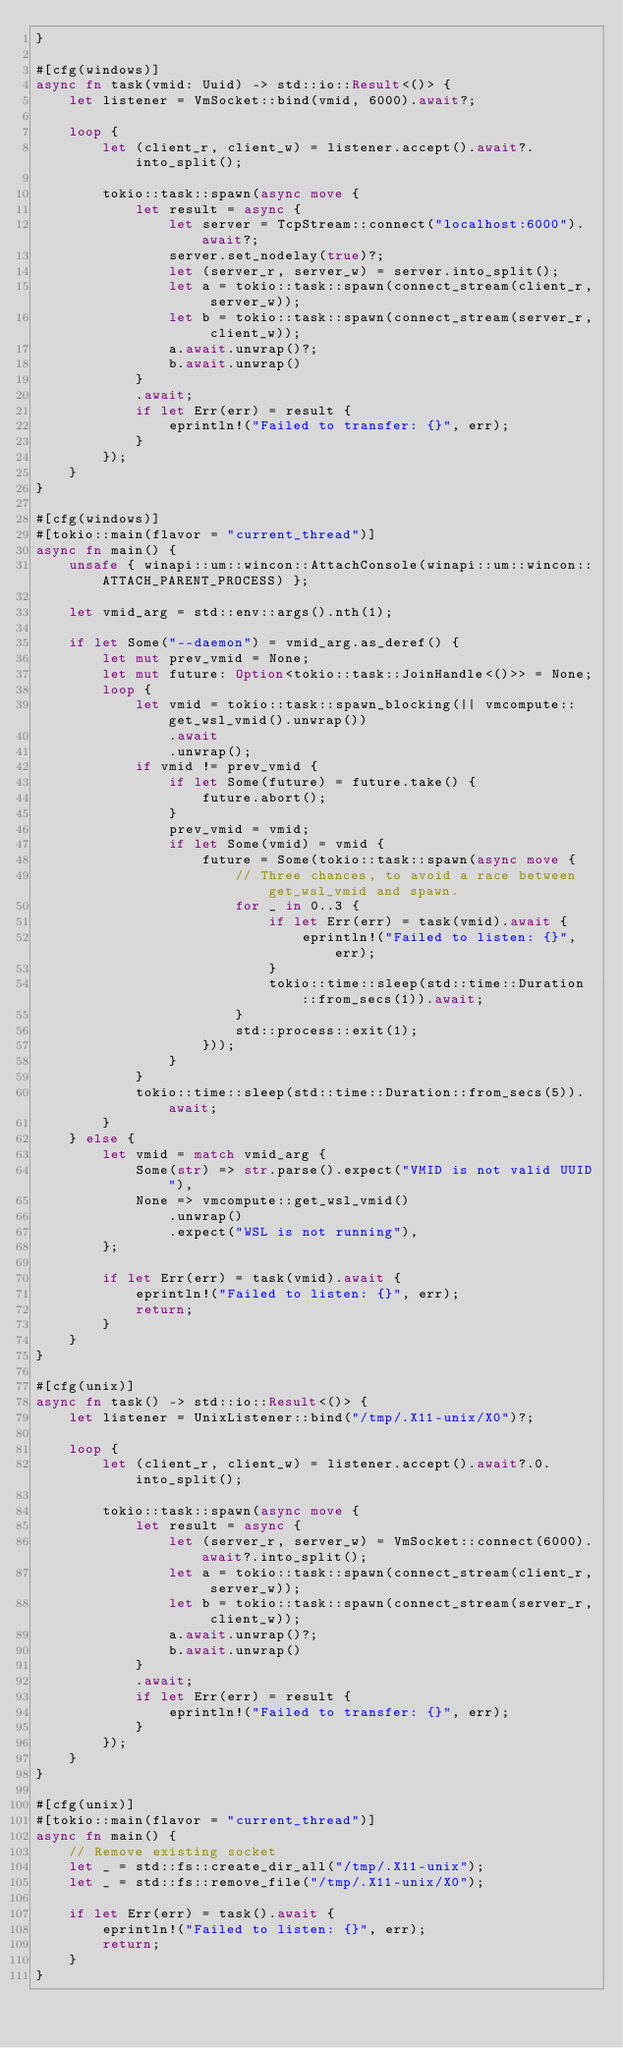Convert code to text. <code><loc_0><loc_0><loc_500><loc_500><_Rust_>}

#[cfg(windows)]
async fn task(vmid: Uuid) -> std::io::Result<()> {
    let listener = VmSocket::bind(vmid, 6000).await?;

    loop {
        let (client_r, client_w) = listener.accept().await?.into_split();

        tokio::task::spawn(async move {
            let result = async {
                let server = TcpStream::connect("localhost:6000").await?;
                server.set_nodelay(true)?;
                let (server_r, server_w) = server.into_split();
                let a = tokio::task::spawn(connect_stream(client_r, server_w));
                let b = tokio::task::spawn(connect_stream(server_r, client_w));
                a.await.unwrap()?;
                b.await.unwrap()
            }
            .await;
            if let Err(err) = result {
                eprintln!("Failed to transfer: {}", err);
            }
        });
    }
}

#[cfg(windows)]
#[tokio::main(flavor = "current_thread")]
async fn main() {
    unsafe { winapi::um::wincon::AttachConsole(winapi::um::wincon::ATTACH_PARENT_PROCESS) };

    let vmid_arg = std::env::args().nth(1);

    if let Some("--daemon") = vmid_arg.as_deref() {
        let mut prev_vmid = None;
        let mut future: Option<tokio::task::JoinHandle<()>> = None;
        loop {
            let vmid = tokio::task::spawn_blocking(|| vmcompute::get_wsl_vmid().unwrap())
                .await
                .unwrap();
            if vmid != prev_vmid {
                if let Some(future) = future.take() {
                    future.abort();
                }
                prev_vmid = vmid;
                if let Some(vmid) = vmid {
                    future = Some(tokio::task::spawn(async move {
                        // Three chances, to avoid a race between get_wsl_vmid and spawn.
                        for _ in 0..3 {
                            if let Err(err) = task(vmid).await {
                                eprintln!("Failed to listen: {}", err);
                            }
                            tokio::time::sleep(std::time::Duration::from_secs(1)).await;
                        }
                        std::process::exit(1);
                    }));
                }
            }
            tokio::time::sleep(std::time::Duration::from_secs(5)).await;
        }
    } else {
        let vmid = match vmid_arg {
            Some(str) => str.parse().expect("VMID is not valid UUID"),
            None => vmcompute::get_wsl_vmid()
                .unwrap()
                .expect("WSL is not running"),
        };

        if let Err(err) = task(vmid).await {
            eprintln!("Failed to listen: {}", err);
            return;
        }
    }
}

#[cfg(unix)]
async fn task() -> std::io::Result<()> {
    let listener = UnixListener::bind("/tmp/.X11-unix/X0")?;

    loop {
        let (client_r, client_w) = listener.accept().await?.0.into_split();

        tokio::task::spawn(async move {
            let result = async {
                let (server_r, server_w) = VmSocket::connect(6000).await?.into_split();
                let a = tokio::task::spawn(connect_stream(client_r, server_w));
                let b = tokio::task::spawn(connect_stream(server_r, client_w));
                a.await.unwrap()?;
                b.await.unwrap()
            }
            .await;
            if let Err(err) = result {
                eprintln!("Failed to transfer: {}", err);
            }
        });
    }
}

#[cfg(unix)]
#[tokio::main(flavor = "current_thread")]
async fn main() {
    // Remove existing socket
    let _ = std::fs::create_dir_all("/tmp/.X11-unix");
    let _ = std::fs::remove_file("/tmp/.X11-unix/X0");

    if let Err(err) = task().await {
        eprintln!("Failed to listen: {}", err);
        return;
    }
}
</code> 